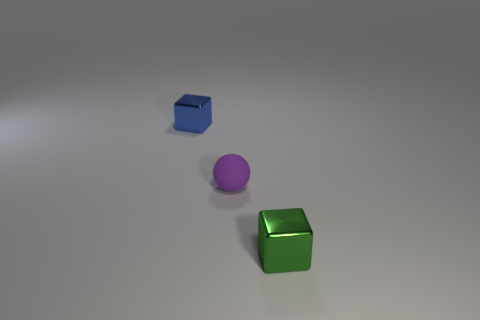Add 1 big green cylinders. How many objects exist? 4 Subtract all balls. How many objects are left? 2 Subtract all big brown matte cubes. Subtract all shiny blocks. How many objects are left? 1 Add 2 tiny things. How many tiny things are left? 5 Add 1 tiny matte objects. How many tiny matte objects exist? 2 Subtract 1 blue cubes. How many objects are left? 2 